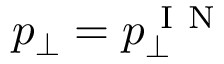Convert formula to latex. <formula><loc_0><loc_0><loc_500><loc_500>p _ { \perp } = p _ { \perp } ^ { I N }</formula> 